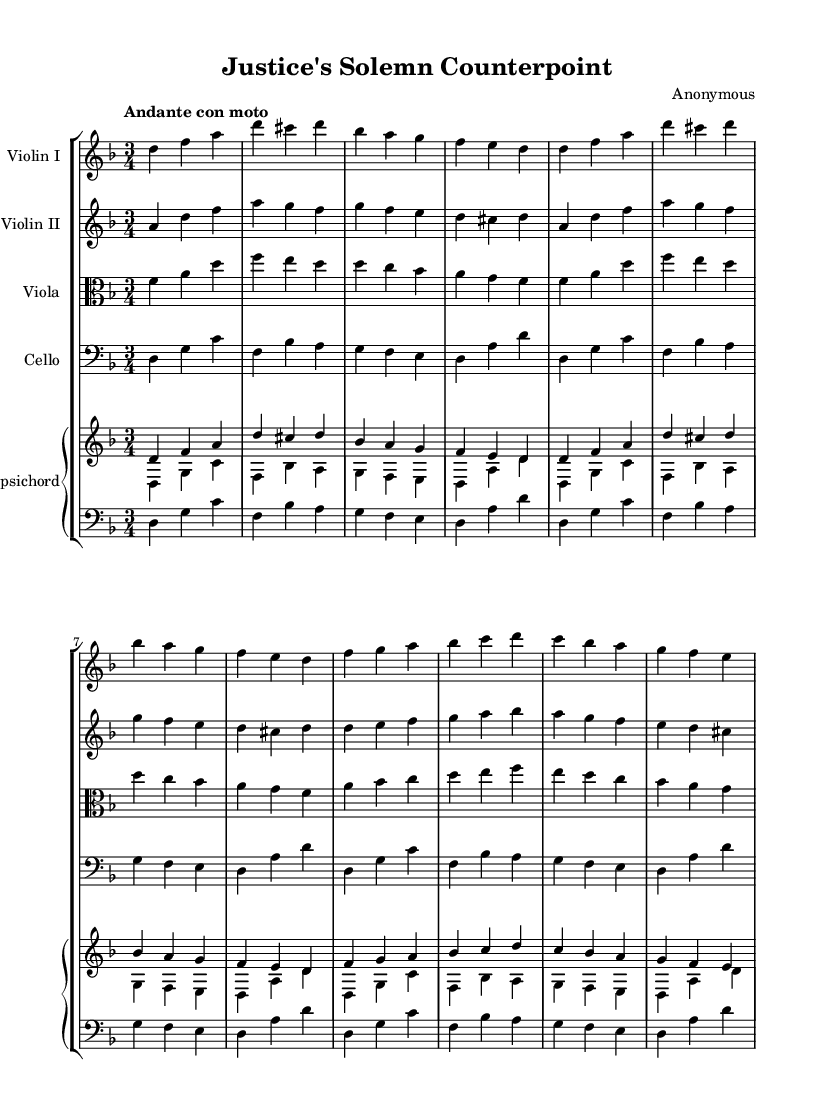What is the key signature of this music? The key signature is indicated by the presence of the flat signs (B flat) on the staff. Here, the music is in D minor, which has one flat (B flat).
Answer: D minor What is the time signature of this music? The time signature is shown at the beginning of the score, displaying the number of beats per measure. In this case, it shows 3 over 4, meaning there are three quarter note beats per measure.
Answer: 3/4 What is the tempo marking at the beginning of the piece? The tempo marking can be seen written above the staff. It indicates the speed of the piece, and in this case, it states "Andante con moto," which suggests a moderately walking pace with some movement.
Answer: Andante con moto How many themes can be identified in the piece? The score outlines two main themes: Theme A and Theme B, each presented in a structured format. By checking the sections labeled as "Theme A" and "Theme B," we see there are two distinct thematic sections.
Answer: Two What instrument plays the bass line throughout the piece? In the score, the cello part is responsible for the bass line as it is written in the bass clef and typically functions as the lowest voice in the ensemble. The notes played by the cello provide the harmonic foundation for the piece.
Answer: Cello Which instruments are included in this chamber music ensemble? The score presents a grouping of parts known as a staff group and lists specific instruments. By examining the individual staves, we can identify Violin I, Violin II, Viola, Cello, and Harpsichord as the instruments in this ensemble.
Answer: Violin I, Violin II, Viola, Cello, Harpsichord Which theme is introduced first in the score? The score clearly lays out the introduction section followed by Theme A. By looking at the titles within the score, we determine that Theme A is the first main theme that follows the introduction.
Answer: Theme A 